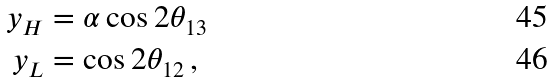Convert formula to latex. <formula><loc_0><loc_0><loc_500><loc_500>y _ { H } & = \alpha \cos 2 \theta _ { 1 3 } \\ y _ { L } & = \cos 2 \theta _ { 1 2 } \, ,</formula> 